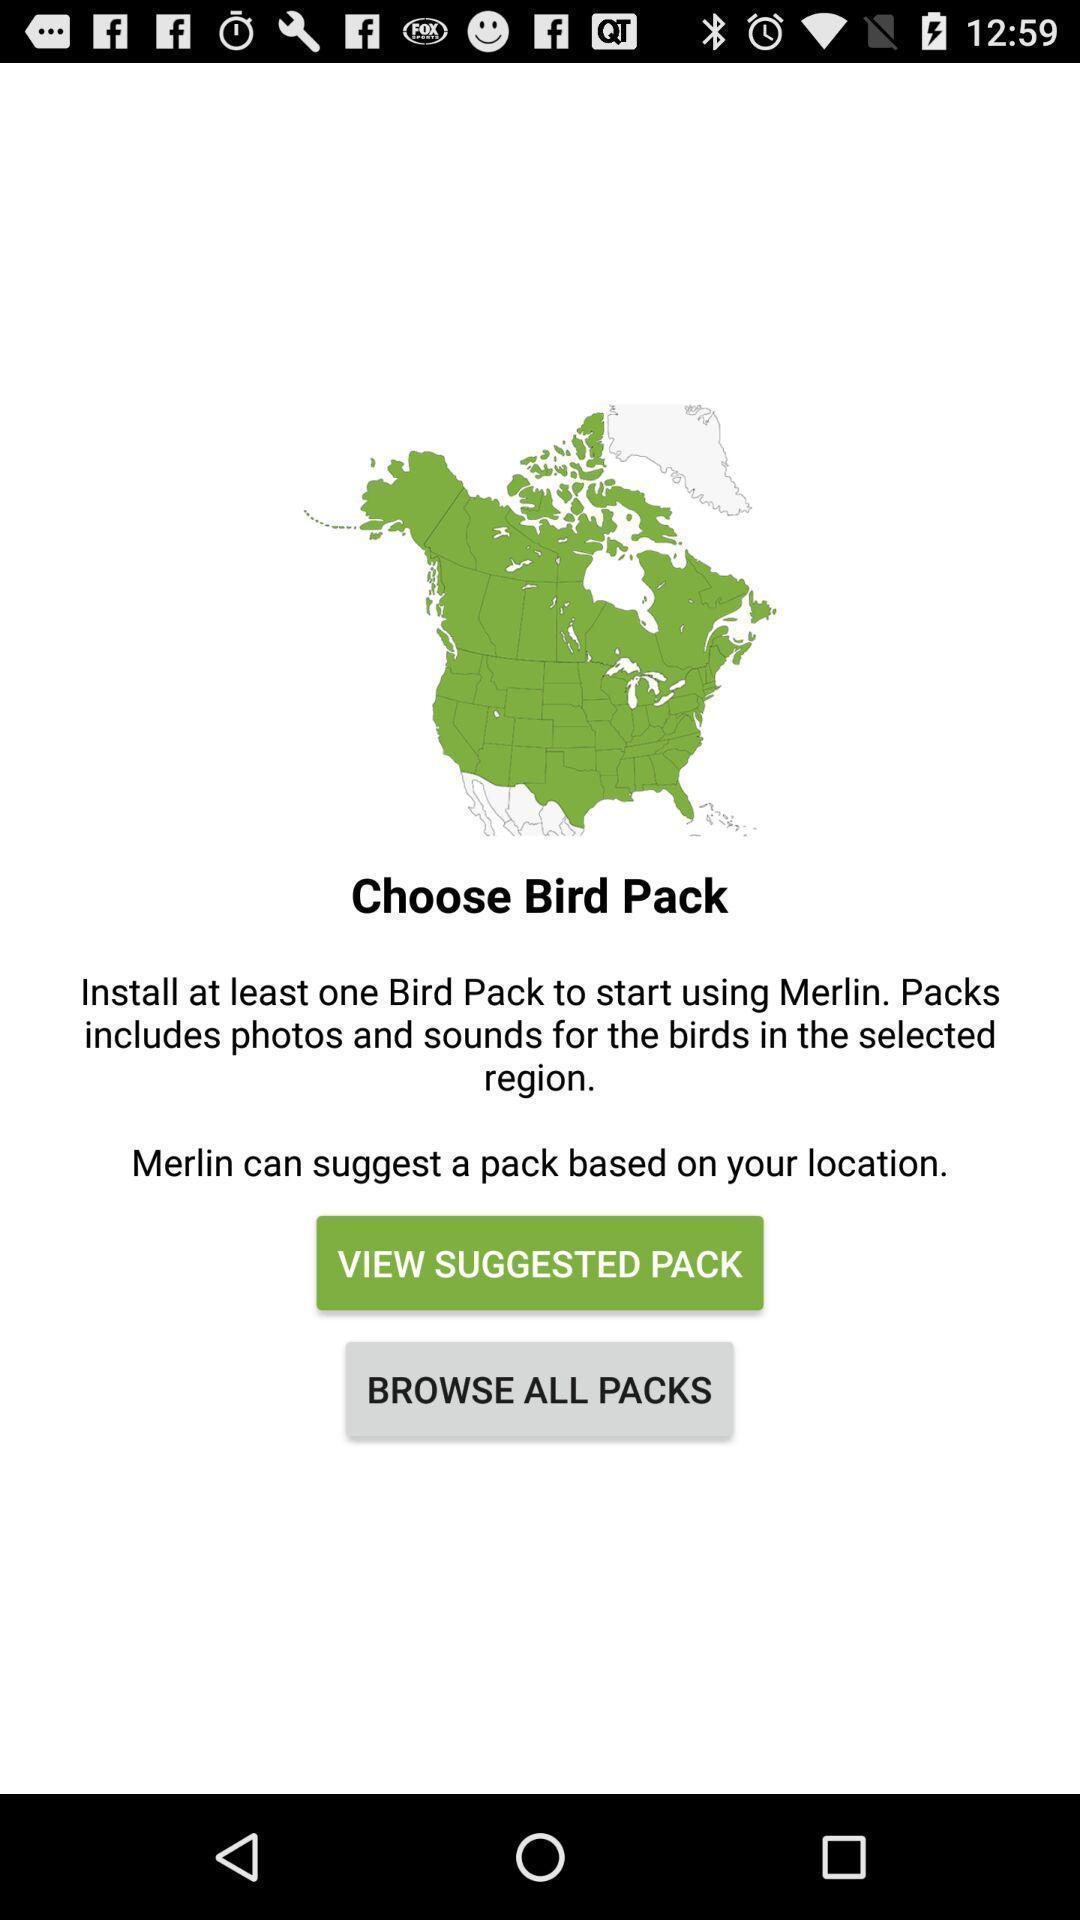What is the overall content of this screenshot? Window displaying a page to find birds. 